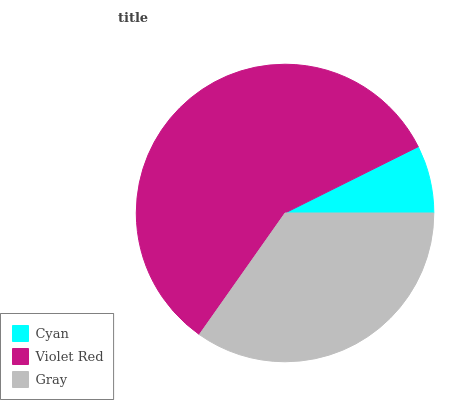Is Cyan the minimum?
Answer yes or no. Yes. Is Violet Red the maximum?
Answer yes or no. Yes. Is Gray the minimum?
Answer yes or no. No. Is Gray the maximum?
Answer yes or no. No. Is Violet Red greater than Gray?
Answer yes or no. Yes. Is Gray less than Violet Red?
Answer yes or no. Yes. Is Gray greater than Violet Red?
Answer yes or no. No. Is Violet Red less than Gray?
Answer yes or no. No. Is Gray the high median?
Answer yes or no. Yes. Is Gray the low median?
Answer yes or no. Yes. Is Violet Red the high median?
Answer yes or no. No. Is Cyan the low median?
Answer yes or no. No. 